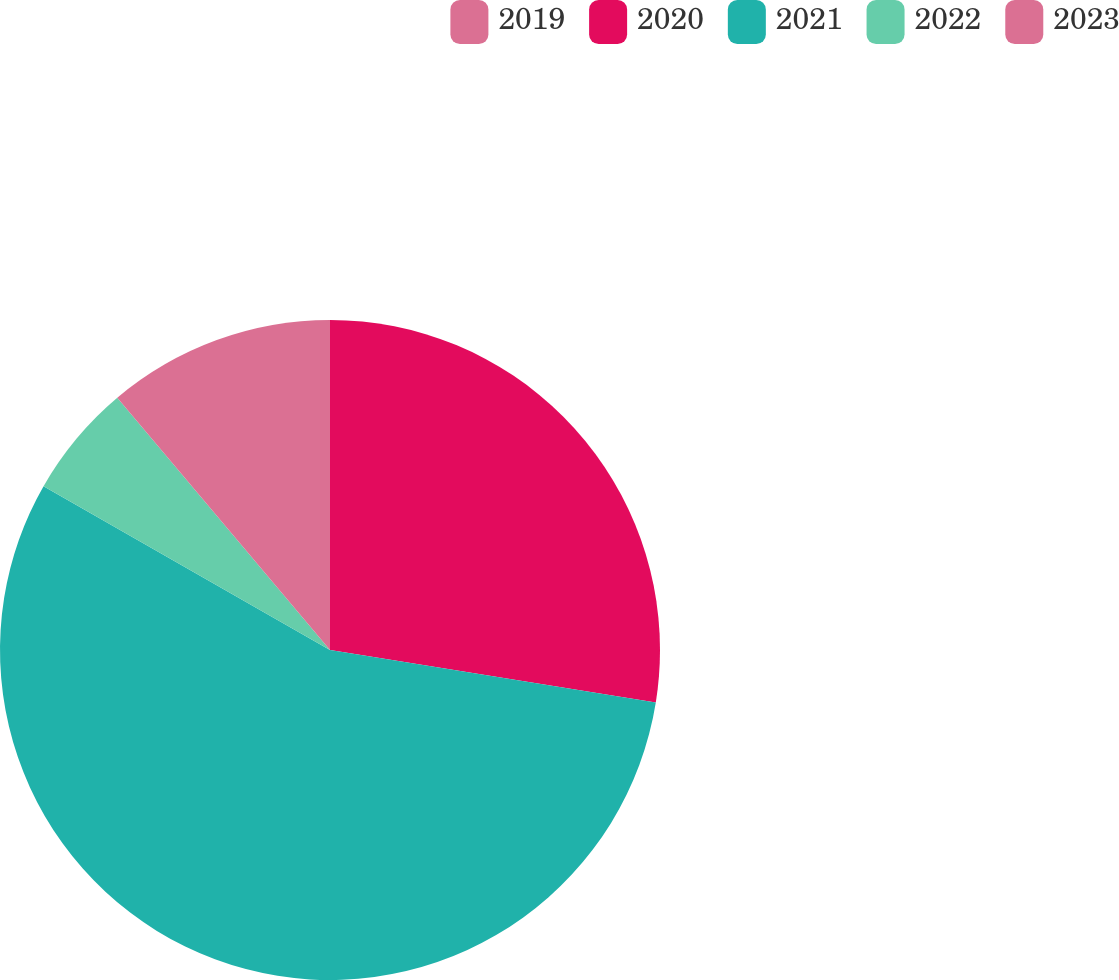Convert chart to OTSL. <chart><loc_0><loc_0><loc_500><loc_500><pie_chart><fcel>2019<fcel>2020<fcel>2021<fcel>2022<fcel>2023<nl><fcel>0.0%<fcel>27.54%<fcel>55.73%<fcel>5.58%<fcel>11.15%<nl></chart> 